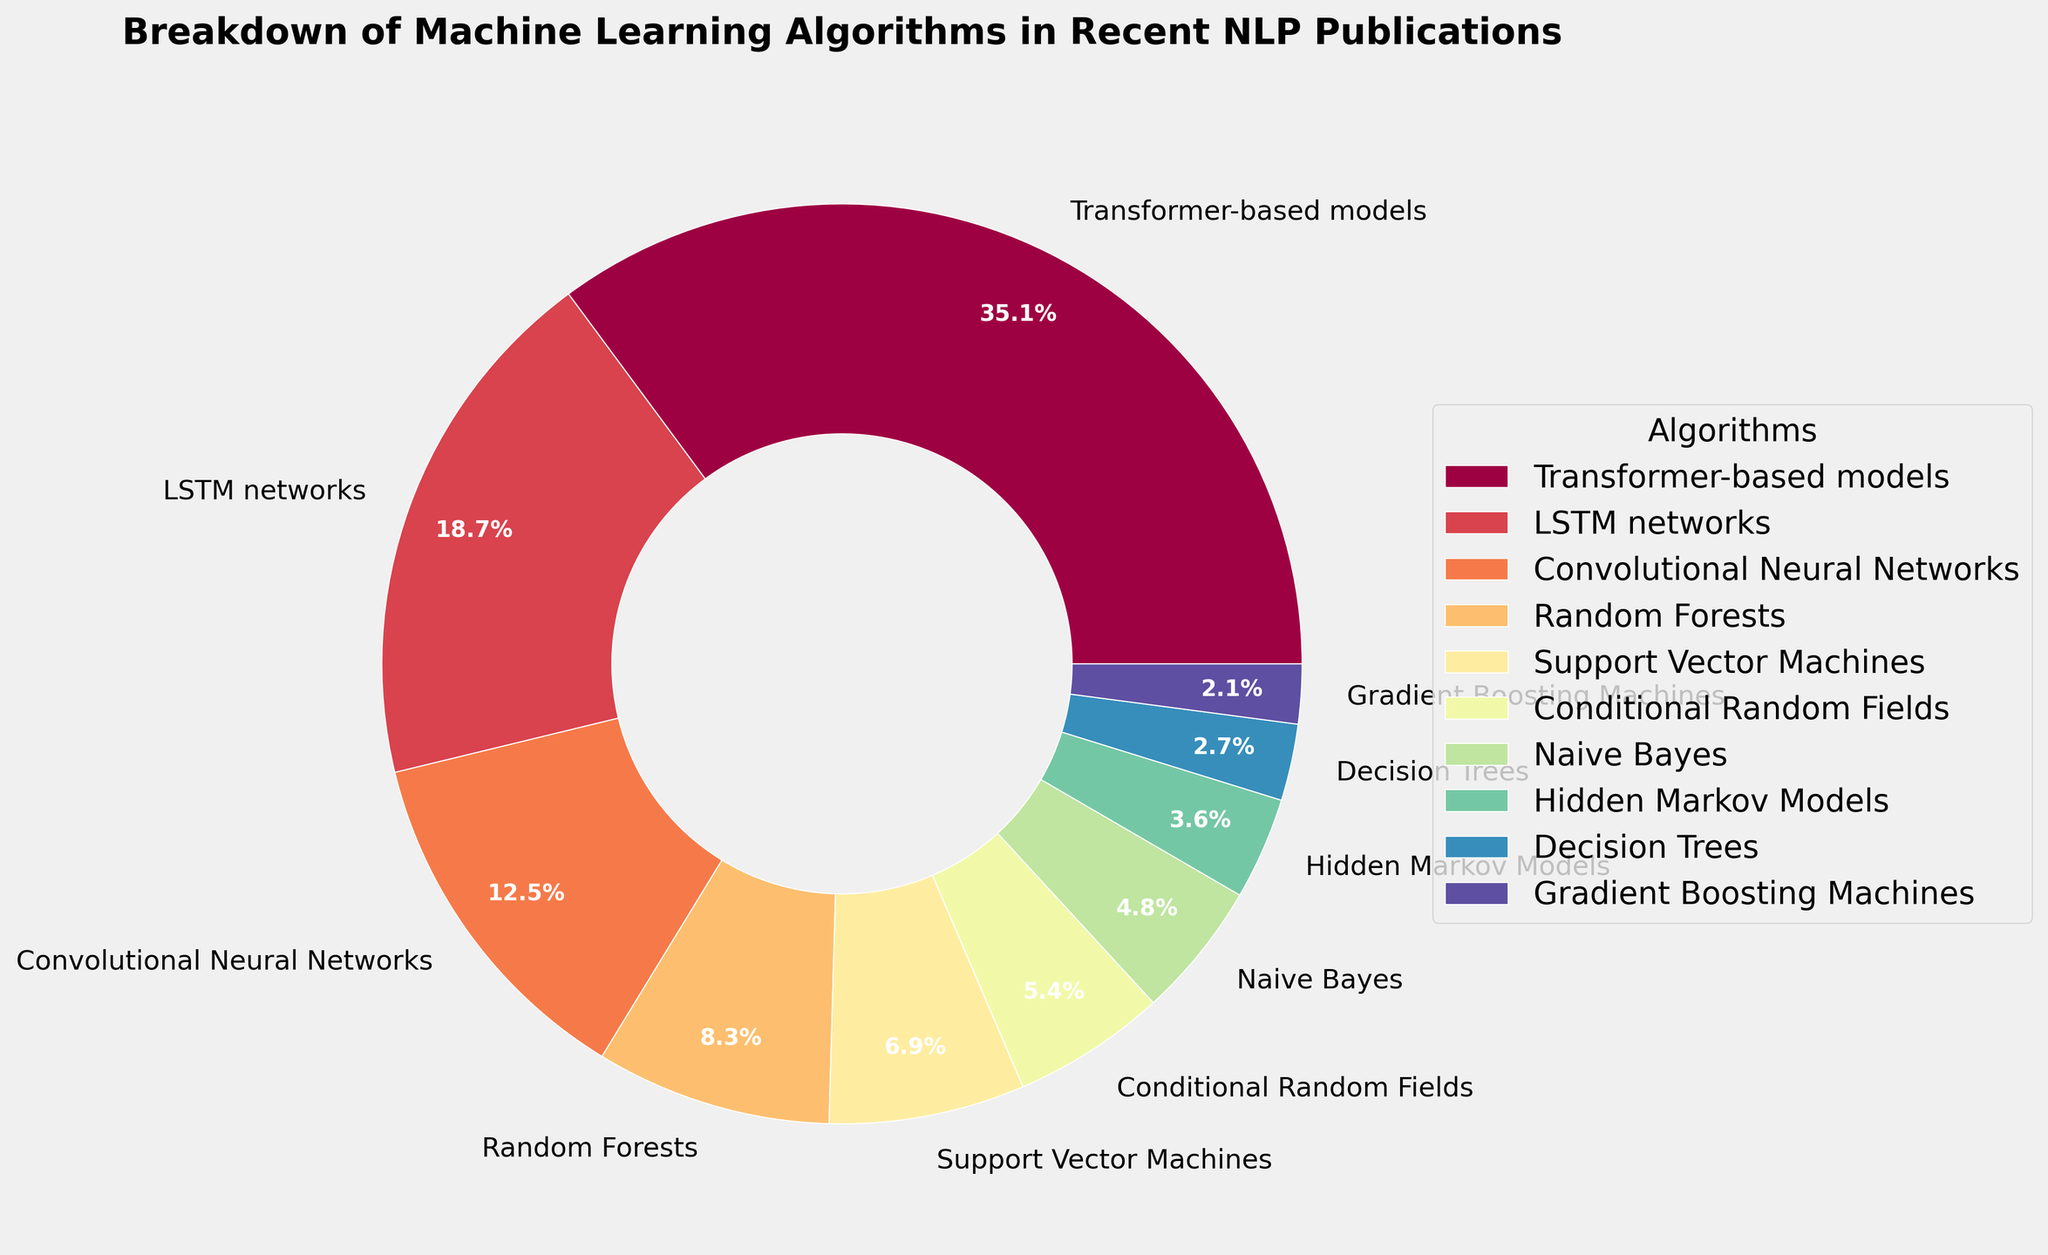Which algorithm has the highest percentage usage in recent NLP publications? The figure shows a pie chart with different segments representing percentages for each algorithm. The largest segment corresponds to Transformer-based models at 35.2%.
Answer: Transformer-based models What is the combined percentage of LSTM networks and Convolutional Neural Networks? The percentages for LSTM networks and Convolutional Neural Networks are 18.7% and 12.5%, respectively. Adding these together results in 18.7 + 12.5 = 31.2%.
Answer: 31.2% How much more popular are Transformer-based models compared to Random Forests? Transformer-based models have a percentage of 35.2%, while Random Forests have 8.3%. The difference is 35.2 - 8.3 = 26.9%.
Answer: 26.9% Which two algorithms have the closest percentages? By examining the percentages, the two algorithms with the closest values are Conditional Random Fields (5.4%) and Naive Bayes (4.8%), which differ by 5.4 - 4.8 = 0.6%.
Answer: Conditional Random Fields and Naive Bayes What percentage of algorithms fall below 10% usage? The algorithms below 10% usage are Random Forests (8.3%), SVM (6.9%), Conditional Random Fields (5.4%), Naive Bayes (4.8%), HMM (3.6%), Decision Trees (2.7%), and Gradient Boosting Machines (2.1%). Summing these gives 8.3 + 6.9 + 5.4 + 4.8 + 3.6 + 2.7 + 2.1 = 33.8%.
Answer: 33.8% Which algorithm has the smallest percentage and what is that percentage? The smallest percentage is associated with Gradient Boosting Machines, which has a value of 2.1%.
Answer: Gradient Boosting Machines, 2.1% How does the usage of Naive Bayes compare to that of Hidden Markov Models? Naive Bayes has 4.8% usage whereas Hidden Markov Models have 3.6% usage. Naive Bayes is more used by 4.8 - 3.6 = 1.2%.
Answer: Naive Bayes is 1.2% more used than Hidden Markov Models What is the total percentage of usage for traditional machine learning algorithms (Random Forests, SVM, CRF, Naive Bayes, HMM, Decision Trees, GBMs)? Summing the percentages for Random Forests (8.3%), SVM (6.9%), CRF (5.4%), Naive Bayes (4.8%), HMM (3.6%), Decision Trees (2.7%), and GBMs (2.1%) results in 8.3 + 6.9 + 5.4 + 4.8 + 3.6 + 2.7 + 2.1 = 33.8%.
Answer: 33.8% What proportion of the pie is represented by deep learning algorithms (Transformer-based models, LSTM networks, ConvNets)? The deep learning algorithms' percentages are Transformer-based models (35.2%), LSTM networks (18.7%), and ConvNets (12.5%). Their sum is 35.2 + 18.7 + 12.5 = 66.4%.
Answer: 66.4% 